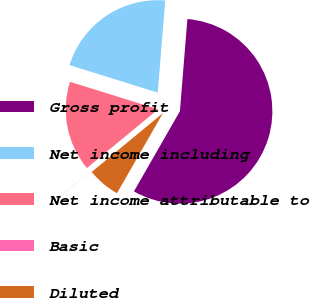<chart> <loc_0><loc_0><loc_500><loc_500><pie_chart><fcel>Gross profit<fcel>Net income including<fcel>Net income attributable to<fcel>Basic<fcel>Diluted<nl><fcel>57.0%<fcel>21.48%<fcel>15.78%<fcel>0.02%<fcel>5.72%<nl></chart> 